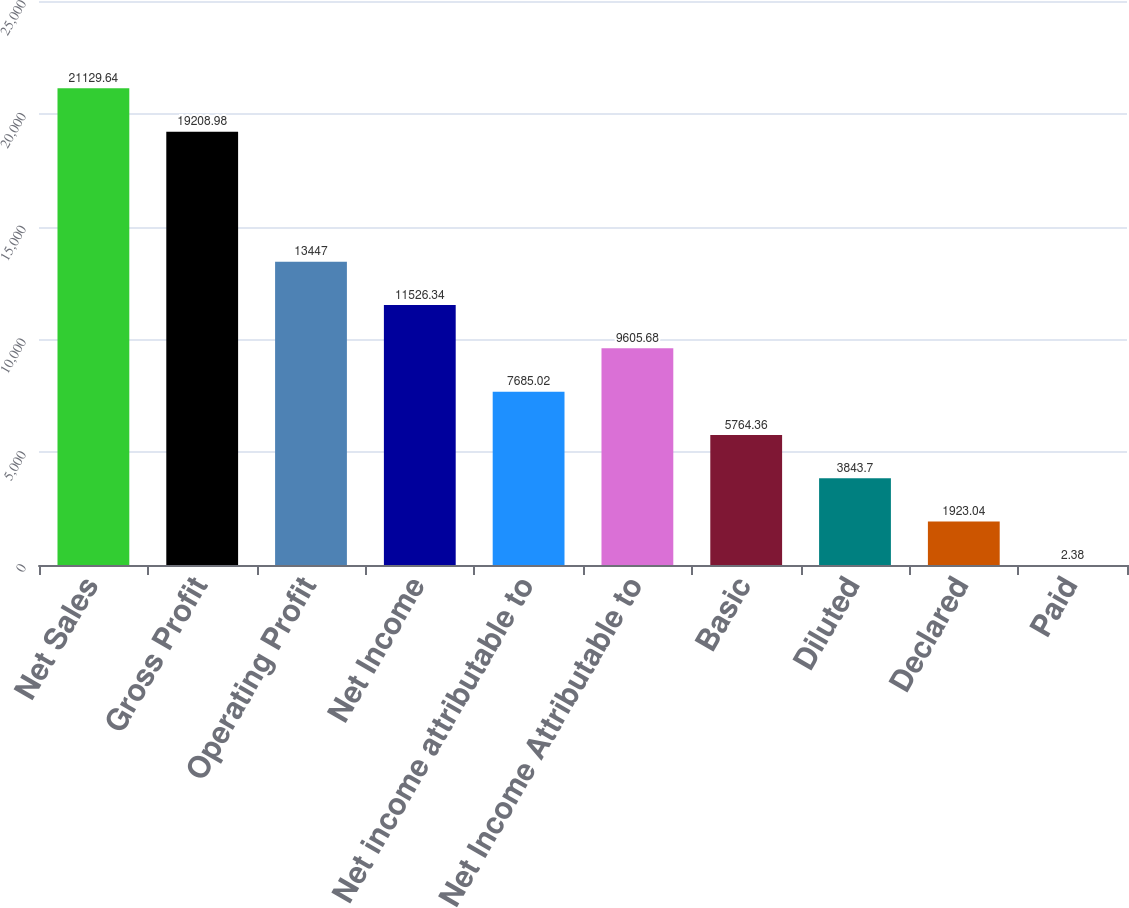<chart> <loc_0><loc_0><loc_500><loc_500><bar_chart><fcel>Net Sales<fcel>Gross Profit<fcel>Operating Profit<fcel>Net Income<fcel>Net income attributable to<fcel>Net Income Attributable to<fcel>Basic<fcel>Diluted<fcel>Declared<fcel>Paid<nl><fcel>21129.6<fcel>19209<fcel>13447<fcel>11526.3<fcel>7685.02<fcel>9605.68<fcel>5764.36<fcel>3843.7<fcel>1923.04<fcel>2.38<nl></chart> 